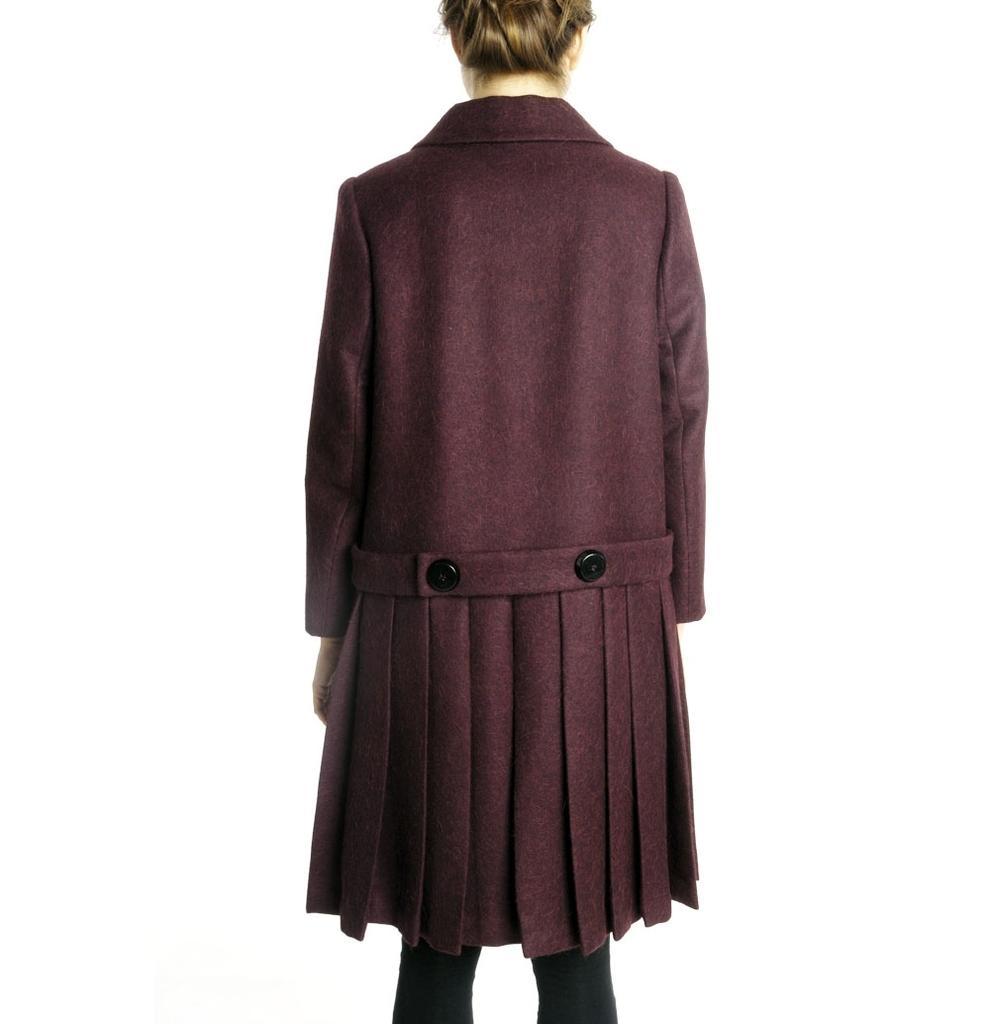Could you give a brief overview of what you see in this image? In this image I can see the person wearing the dress which is in maroon and black color. And there is a white background. 